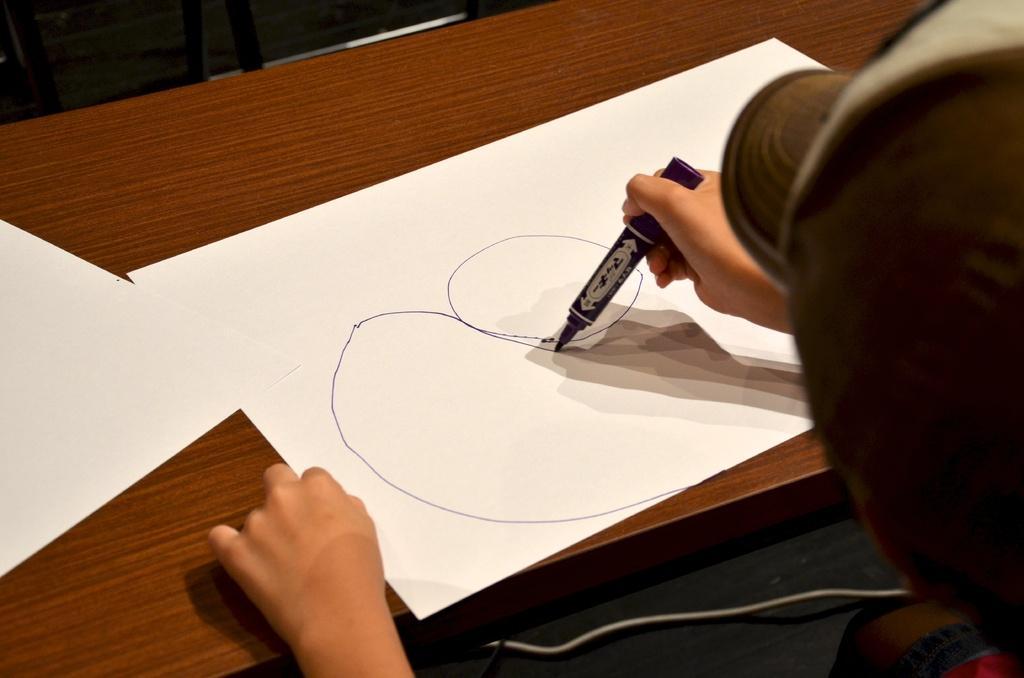Could you give a brief overview of what you see in this image? on the table there is a paper and a person is drawing on the paper. 